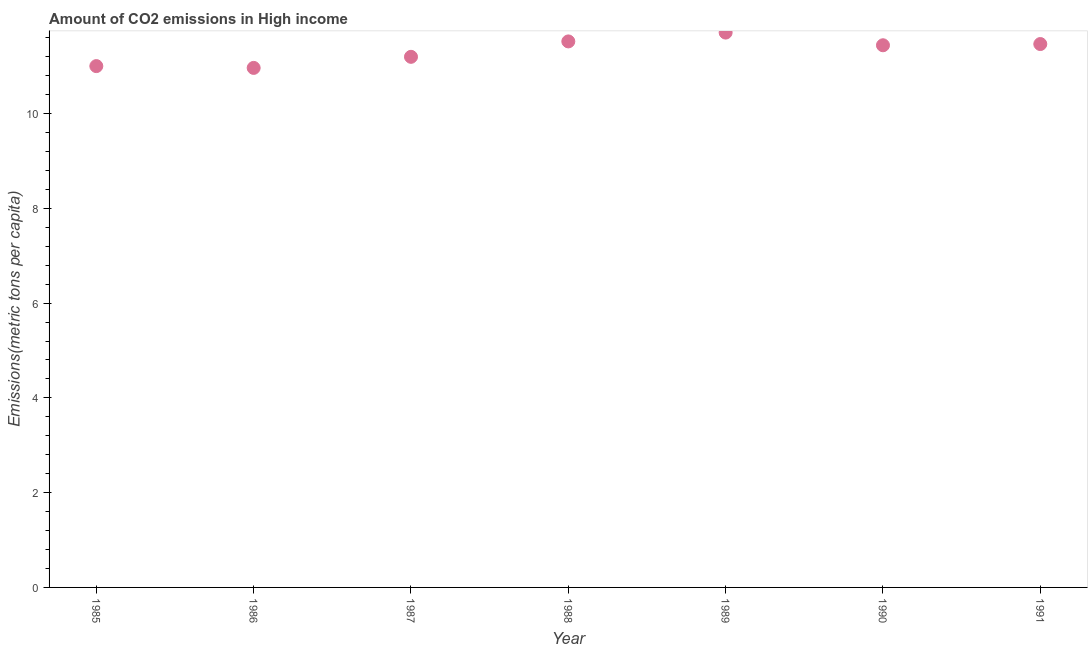What is the amount of co2 emissions in 1991?
Your answer should be very brief. 11.47. Across all years, what is the maximum amount of co2 emissions?
Your answer should be compact. 11.71. Across all years, what is the minimum amount of co2 emissions?
Your response must be concise. 10.96. In which year was the amount of co2 emissions maximum?
Offer a terse response. 1989. What is the sum of the amount of co2 emissions?
Your response must be concise. 79.3. What is the difference between the amount of co2 emissions in 1989 and 1990?
Offer a terse response. 0.27. What is the average amount of co2 emissions per year?
Make the answer very short. 11.33. What is the median amount of co2 emissions?
Give a very brief answer. 11.44. Do a majority of the years between 1985 and 1990 (inclusive) have amount of co2 emissions greater than 9.2 metric tons per capita?
Ensure brevity in your answer.  Yes. What is the ratio of the amount of co2 emissions in 1985 to that in 1987?
Provide a short and direct response. 0.98. Is the amount of co2 emissions in 1988 less than that in 1990?
Your answer should be very brief. No. Is the difference between the amount of co2 emissions in 1987 and 1991 greater than the difference between any two years?
Provide a succinct answer. No. What is the difference between the highest and the second highest amount of co2 emissions?
Your answer should be very brief. 0.19. What is the difference between the highest and the lowest amount of co2 emissions?
Provide a short and direct response. 0.75. Does the amount of co2 emissions monotonically increase over the years?
Offer a very short reply. No. How many dotlines are there?
Your answer should be compact. 1. How many years are there in the graph?
Give a very brief answer. 7. What is the difference between two consecutive major ticks on the Y-axis?
Offer a very short reply. 2. Does the graph contain grids?
Keep it short and to the point. No. What is the title of the graph?
Your response must be concise. Amount of CO2 emissions in High income. What is the label or title of the Y-axis?
Provide a short and direct response. Emissions(metric tons per capita). What is the Emissions(metric tons per capita) in 1985?
Make the answer very short. 11. What is the Emissions(metric tons per capita) in 1986?
Your answer should be very brief. 10.96. What is the Emissions(metric tons per capita) in 1987?
Provide a succinct answer. 11.2. What is the Emissions(metric tons per capita) in 1988?
Ensure brevity in your answer.  11.52. What is the Emissions(metric tons per capita) in 1989?
Your answer should be very brief. 11.71. What is the Emissions(metric tons per capita) in 1990?
Ensure brevity in your answer.  11.44. What is the Emissions(metric tons per capita) in 1991?
Keep it short and to the point. 11.47. What is the difference between the Emissions(metric tons per capita) in 1985 and 1986?
Offer a terse response. 0.04. What is the difference between the Emissions(metric tons per capita) in 1985 and 1987?
Your answer should be very brief. -0.2. What is the difference between the Emissions(metric tons per capita) in 1985 and 1988?
Offer a terse response. -0.52. What is the difference between the Emissions(metric tons per capita) in 1985 and 1989?
Ensure brevity in your answer.  -0.71. What is the difference between the Emissions(metric tons per capita) in 1985 and 1990?
Provide a succinct answer. -0.44. What is the difference between the Emissions(metric tons per capita) in 1985 and 1991?
Offer a very short reply. -0.47. What is the difference between the Emissions(metric tons per capita) in 1986 and 1987?
Your answer should be compact. -0.23. What is the difference between the Emissions(metric tons per capita) in 1986 and 1988?
Your response must be concise. -0.56. What is the difference between the Emissions(metric tons per capita) in 1986 and 1989?
Provide a succinct answer. -0.75. What is the difference between the Emissions(metric tons per capita) in 1986 and 1990?
Your response must be concise. -0.48. What is the difference between the Emissions(metric tons per capita) in 1986 and 1991?
Your response must be concise. -0.5. What is the difference between the Emissions(metric tons per capita) in 1987 and 1988?
Give a very brief answer. -0.33. What is the difference between the Emissions(metric tons per capita) in 1987 and 1989?
Make the answer very short. -0.51. What is the difference between the Emissions(metric tons per capita) in 1987 and 1990?
Provide a short and direct response. -0.24. What is the difference between the Emissions(metric tons per capita) in 1987 and 1991?
Your response must be concise. -0.27. What is the difference between the Emissions(metric tons per capita) in 1988 and 1989?
Your response must be concise. -0.19. What is the difference between the Emissions(metric tons per capita) in 1988 and 1990?
Offer a very short reply. 0.08. What is the difference between the Emissions(metric tons per capita) in 1988 and 1991?
Your response must be concise. 0.06. What is the difference between the Emissions(metric tons per capita) in 1989 and 1990?
Give a very brief answer. 0.27. What is the difference between the Emissions(metric tons per capita) in 1989 and 1991?
Give a very brief answer. 0.24. What is the difference between the Emissions(metric tons per capita) in 1990 and 1991?
Give a very brief answer. -0.03. What is the ratio of the Emissions(metric tons per capita) in 1985 to that in 1986?
Make the answer very short. 1. What is the ratio of the Emissions(metric tons per capita) in 1985 to that in 1987?
Offer a very short reply. 0.98. What is the ratio of the Emissions(metric tons per capita) in 1985 to that in 1988?
Offer a terse response. 0.95. What is the ratio of the Emissions(metric tons per capita) in 1985 to that in 1990?
Your response must be concise. 0.96. What is the ratio of the Emissions(metric tons per capita) in 1986 to that in 1988?
Give a very brief answer. 0.95. What is the ratio of the Emissions(metric tons per capita) in 1986 to that in 1989?
Your answer should be very brief. 0.94. What is the ratio of the Emissions(metric tons per capita) in 1986 to that in 1990?
Keep it short and to the point. 0.96. What is the ratio of the Emissions(metric tons per capita) in 1986 to that in 1991?
Provide a short and direct response. 0.96. What is the ratio of the Emissions(metric tons per capita) in 1987 to that in 1988?
Your response must be concise. 0.97. What is the ratio of the Emissions(metric tons per capita) in 1987 to that in 1989?
Provide a short and direct response. 0.96. What is the ratio of the Emissions(metric tons per capita) in 1987 to that in 1990?
Provide a succinct answer. 0.98. What is the ratio of the Emissions(metric tons per capita) in 1987 to that in 1991?
Give a very brief answer. 0.98. What is the ratio of the Emissions(metric tons per capita) in 1988 to that in 1989?
Provide a succinct answer. 0.98. What is the ratio of the Emissions(metric tons per capita) in 1988 to that in 1990?
Keep it short and to the point. 1.01. What is the ratio of the Emissions(metric tons per capita) in 1988 to that in 1991?
Keep it short and to the point. 1. What is the ratio of the Emissions(metric tons per capita) in 1989 to that in 1990?
Provide a succinct answer. 1.02. What is the ratio of the Emissions(metric tons per capita) in 1989 to that in 1991?
Offer a terse response. 1.02. 